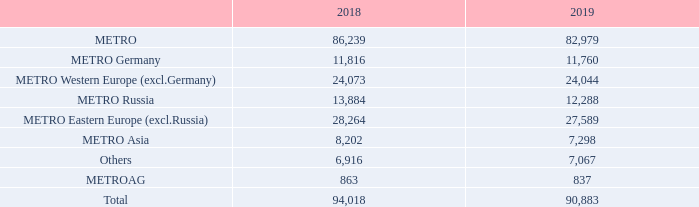DEVELOPMENT OF EMPLOYEE NUMBERS BY SEGMENTS
Full-time equivalents1 as of the closing date of 30/9
1 Excluding METRO China.
When were the employee numbers by segments calculated? As of the closing date of 30/9. What was excluded in the full-time equivalents as of the closing date of 30/9? Metro china. What were the components under METRO in the table when accounting for the employee numbers by segments? Metro germany, metro western europe (excl.germany), metro russia, metro eastern europe (excl.russia), metro asia. In which year was the amount for METRO AG larger? 863>837
Answer: 2018. What was the change in METRO AG in 2019 from 2018? 837-863
Answer: -26. What was the percentage change in METRO AG in 2019 from 2018?
Answer scale should be: percent. (837-863)/863
Answer: -3.01. 